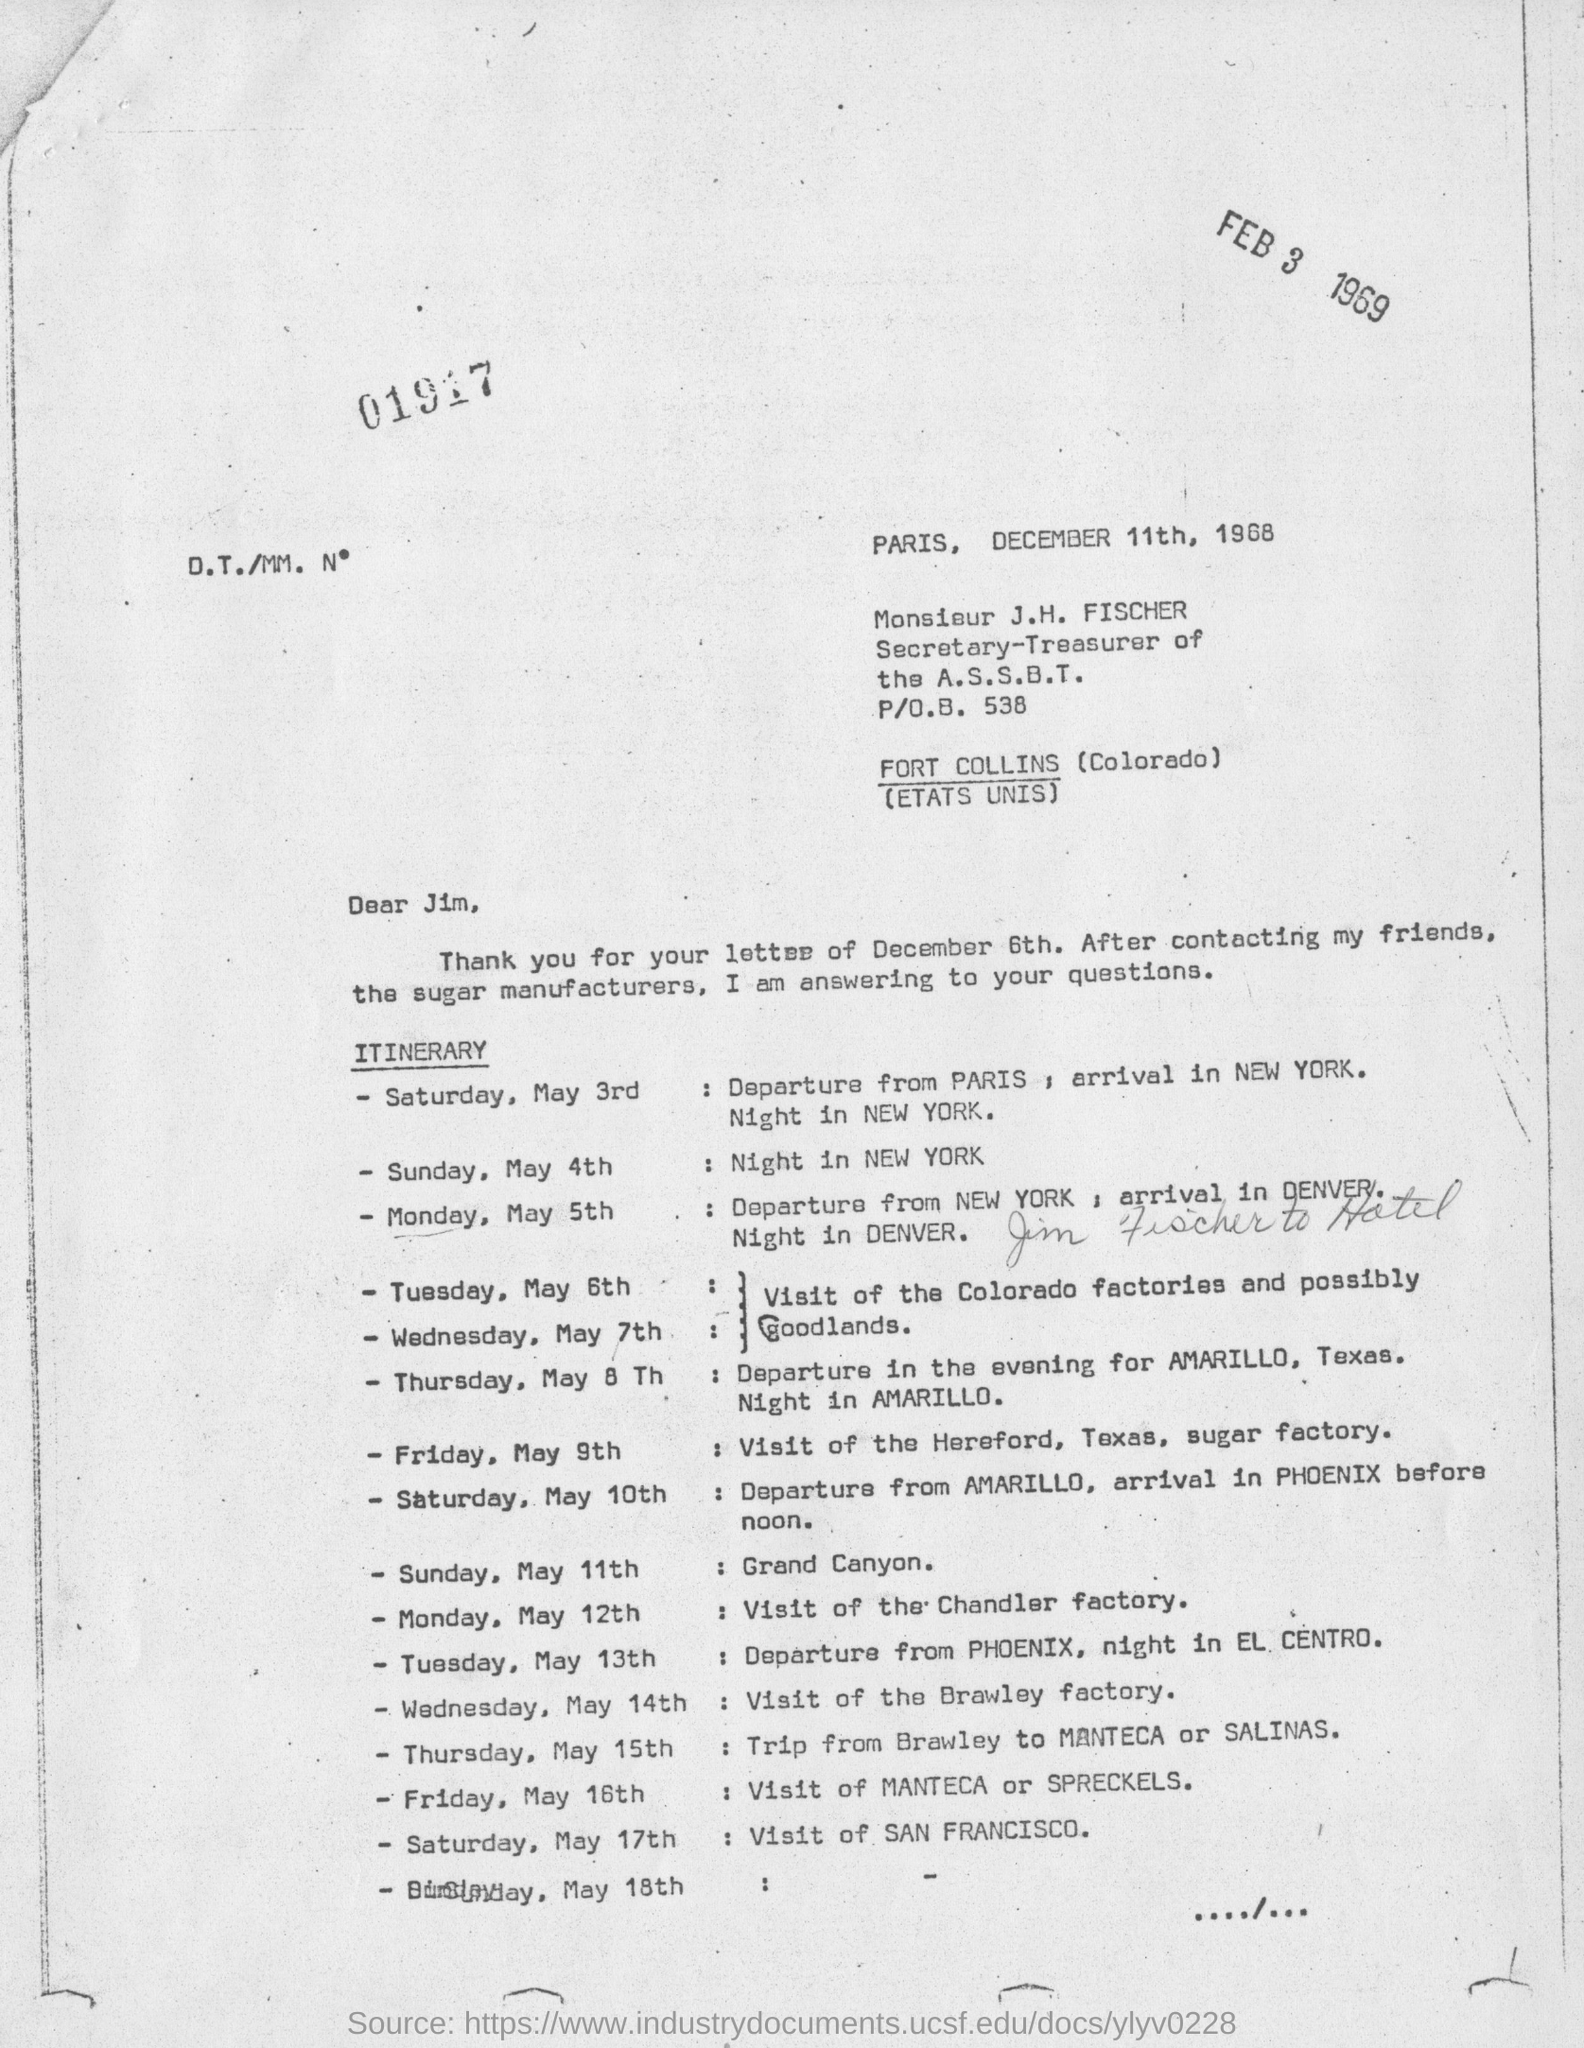Point out several critical features in this image. The letter is dated December 11th, 1968. On Sunday, May 11th, the visit is scheduled to the Grand Canyon. 